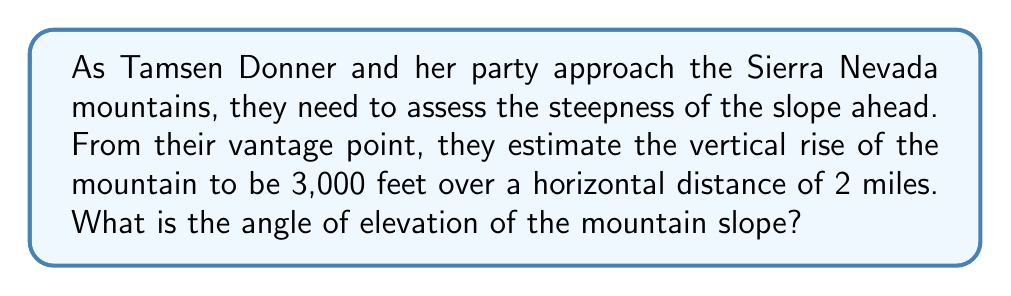Teach me how to tackle this problem. To solve this problem, we'll use trigonometry, specifically the tangent function. Let's approach this step-by-step:

1) First, we need to ensure our units are consistent. Let's convert 2 miles to feet:
   $2 \text{ miles} = 2 \times 5280 \text{ feet} = 10,560 \text{ feet}$

2) Now we have a right triangle where:
   - The opposite side (vertical rise) is 3,000 feet
   - The adjacent side (horizontal distance) is 10,560 feet
   - The angle we're looking for is the angle of elevation

3) We can represent this situation with the following diagram:

   [asy]
   import geometry;
   
   size(200);
   
   pair A = (0,0), B = (10.56,0), C = (10.56,3);
   
   draw(A--B--C--A);
   
   label("3,000 ft", (10.7,1.5), E);
   label("10,560 ft", (5.28,-0.3), S);
   label("$\theta$", (0.3,0.1), NW);
   
   draw(rightanglemark(A,B,C,2));
   [/asy]

4) The tangent of an angle in a right triangle is the ratio of the opposite side to the adjacent side:

   $\tan \theta = \frac{\text{opposite}}{\text{adjacent}} = \frac{3000}{10560}$

5) To find the angle, we need to use the inverse tangent (arctan or $\tan^{-1}$):

   $\theta = \tan^{-1}\left(\frac{3000}{10560}\right)$

6) Using a calculator or computer:

   $\theta \approx 15.86°$

Therefore, the angle of elevation of the mountain slope is approximately 15.86°.
Answer: $15.86°$ 